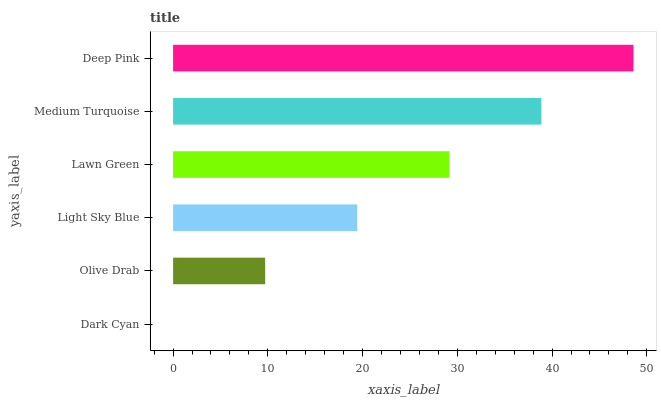Is Dark Cyan the minimum?
Answer yes or no. Yes. Is Deep Pink the maximum?
Answer yes or no. Yes. Is Olive Drab the minimum?
Answer yes or no. No. Is Olive Drab the maximum?
Answer yes or no. No. Is Olive Drab greater than Dark Cyan?
Answer yes or no. Yes. Is Dark Cyan less than Olive Drab?
Answer yes or no. Yes. Is Dark Cyan greater than Olive Drab?
Answer yes or no. No. Is Olive Drab less than Dark Cyan?
Answer yes or no. No. Is Lawn Green the high median?
Answer yes or no. Yes. Is Light Sky Blue the low median?
Answer yes or no. Yes. Is Olive Drab the high median?
Answer yes or no. No. Is Dark Cyan the low median?
Answer yes or no. No. 